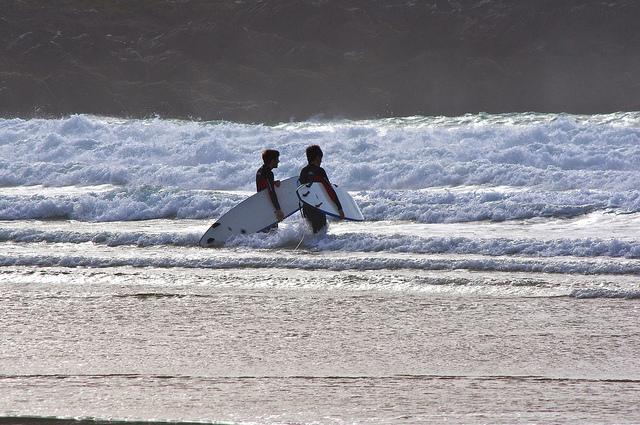What are the two men walking in? Please explain your reasoning. surf. The two men are walking in waves. 